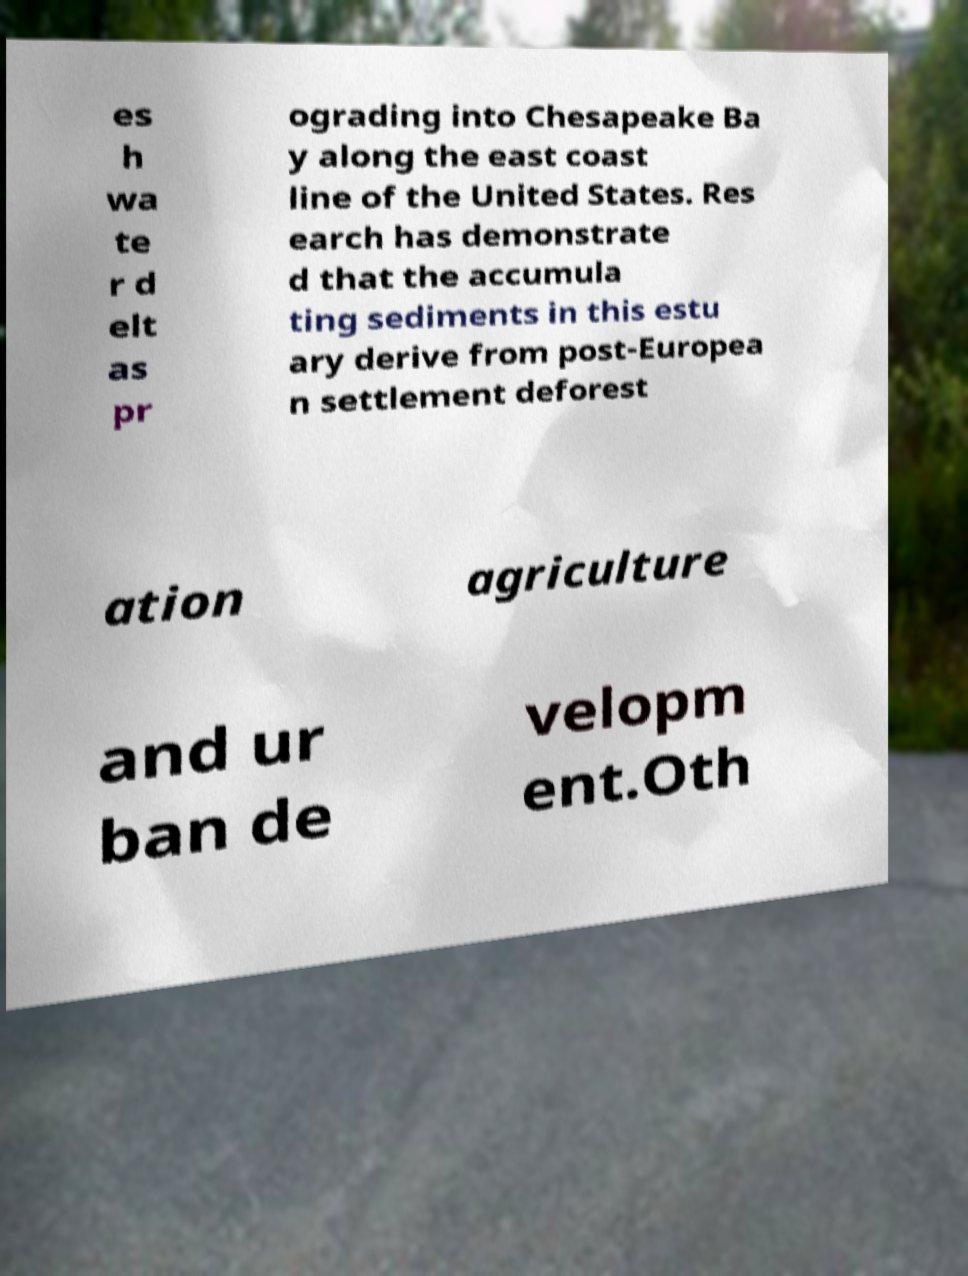Could you extract and type out the text from this image? es h wa te r d elt as pr ograding into Chesapeake Ba y along the east coast line of the United States. Res earch has demonstrate d that the accumula ting sediments in this estu ary derive from post-Europea n settlement deforest ation agriculture and ur ban de velopm ent.Oth 